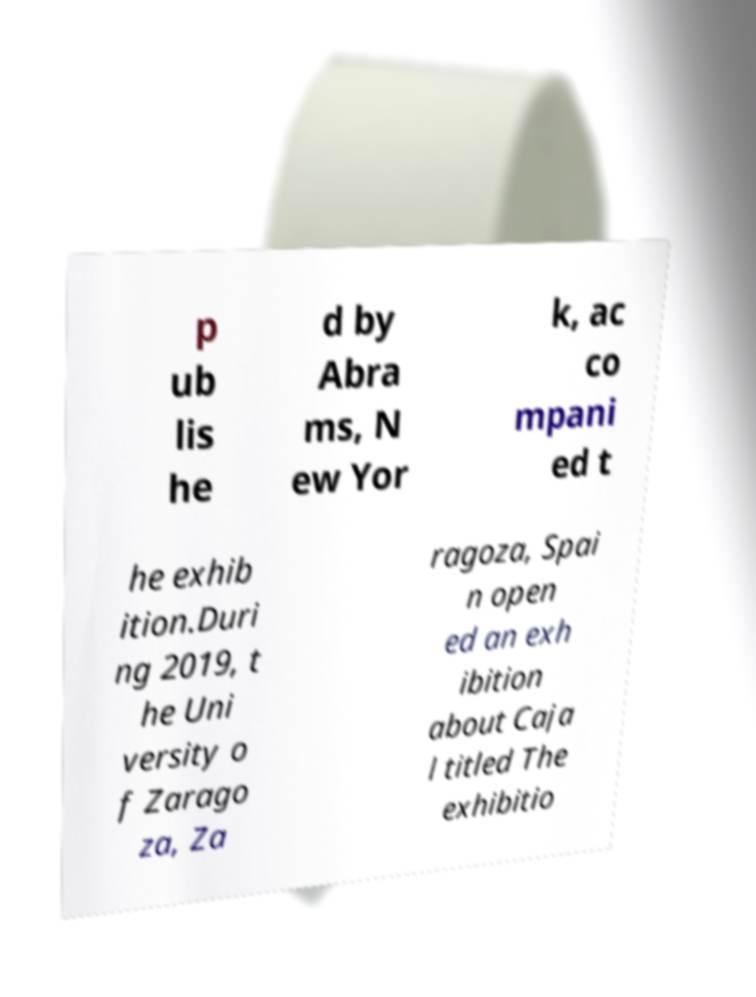Please read and relay the text visible in this image. What does it say? p ub lis he d by Abra ms, N ew Yor k, ac co mpani ed t he exhib ition.Duri ng 2019, t he Uni versity o f Zarago za, Za ragoza, Spai n open ed an exh ibition about Caja l titled The exhibitio 